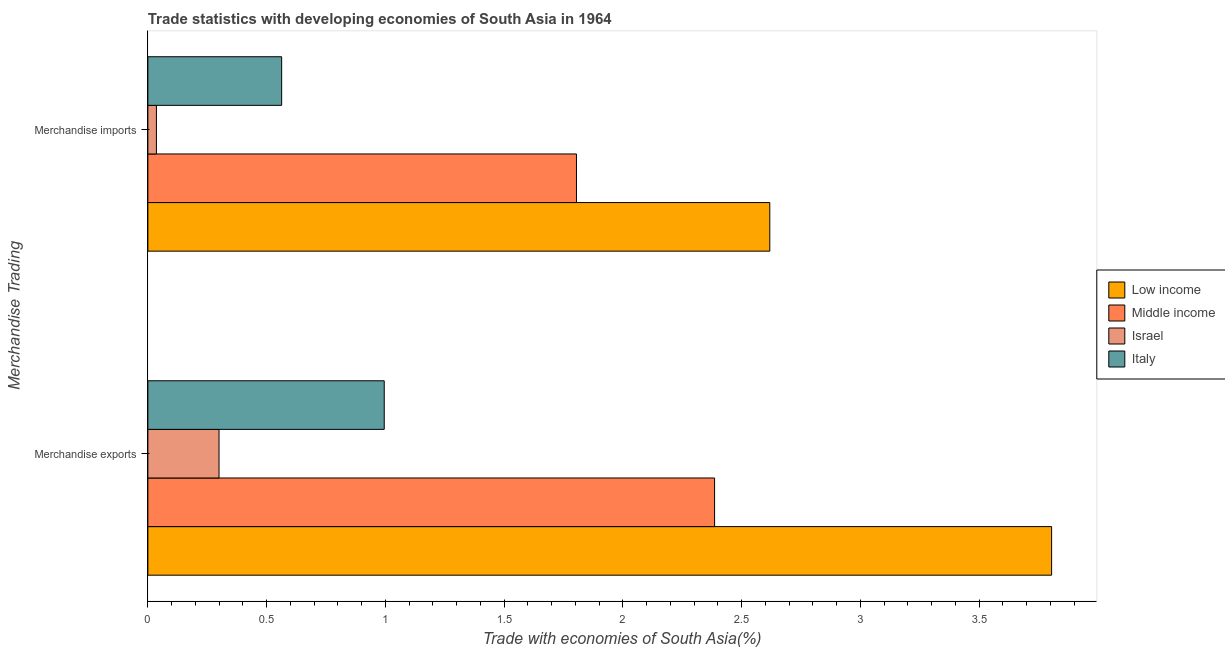How many different coloured bars are there?
Provide a short and direct response. 4. How many bars are there on the 2nd tick from the bottom?
Your answer should be very brief. 4. What is the merchandise imports in Israel?
Keep it short and to the point. 0.04. Across all countries, what is the maximum merchandise exports?
Your answer should be very brief. 3.81. Across all countries, what is the minimum merchandise exports?
Your answer should be compact. 0.3. In which country was the merchandise exports maximum?
Your response must be concise. Low income. In which country was the merchandise imports minimum?
Offer a very short reply. Israel. What is the total merchandise imports in the graph?
Offer a very short reply. 5.02. What is the difference between the merchandise exports in Israel and that in Low income?
Offer a terse response. -3.51. What is the difference between the merchandise exports in Israel and the merchandise imports in Middle income?
Keep it short and to the point. -1.51. What is the average merchandise exports per country?
Offer a very short reply. 1.87. What is the difference between the merchandise imports and merchandise exports in Israel?
Offer a very short reply. -0.26. In how many countries, is the merchandise exports greater than 3.8 %?
Provide a short and direct response. 1. What is the ratio of the merchandise imports in Israel to that in Low income?
Keep it short and to the point. 0.01. Is the merchandise imports in Italy less than that in Low income?
Your response must be concise. Yes. What does the 4th bar from the bottom in Merchandise exports represents?
Provide a short and direct response. Italy. Are all the bars in the graph horizontal?
Make the answer very short. Yes. How many countries are there in the graph?
Give a very brief answer. 4. What is the difference between two consecutive major ticks on the X-axis?
Give a very brief answer. 0.5. Are the values on the major ticks of X-axis written in scientific E-notation?
Ensure brevity in your answer.  No. Does the graph contain grids?
Provide a succinct answer. No. How are the legend labels stacked?
Your response must be concise. Vertical. What is the title of the graph?
Your answer should be very brief. Trade statistics with developing economies of South Asia in 1964. Does "Philippines" appear as one of the legend labels in the graph?
Offer a very short reply. No. What is the label or title of the X-axis?
Ensure brevity in your answer.  Trade with economies of South Asia(%). What is the label or title of the Y-axis?
Provide a succinct answer. Merchandise Trading. What is the Trade with economies of South Asia(%) of Low income in Merchandise exports?
Offer a terse response. 3.81. What is the Trade with economies of South Asia(%) in Middle income in Merchandise exports?
Offer a terse response. 2.39. What is the Trade with economies of South Asia(%) of Israel in Merchandise exports?
Make the answer very short. 0.3. What is the Trade with economies of South Asia(%) of Italy in Merchandise exports?
Provide a short and direct response. 1. What is the Trade with economies of South Asia(%) of Low income in Merchandise imports?
Offer a terse response. 2.62. What is the Trade with economies of South Asia(%) in Middle income in Merchandise imports?
Offer a very short reply. 1.8. What is the Trade with economies of South Asia(%) of Israel in Merchandise imports?
Keep it short and to the point. 0.04. What is the Trade with economies of South Asia(%) in Italy in Merchandise imports?
Make the answer very short. 0.56. Across all Merchandise Trading, what is the maximum Trade with economies of South Asia(%) in Low income?
Provide a succinct answer. 3.81. Across all Merchandise Trading, what is the maximum Trade with economies of South Asia(%) in Middle income?
Ensure brevity in your answer.  2.39. Across all Merchandise Trading, what is the maximum Trade with economies of South Asia(%) in Israel?
Your response must be concise. 0.3. Across all Merchandise Trading, what is the maximum Trade with economies of South Asia(%) of Italy?
Provide a short and direct response. 1. Across all Merchandise Trading, what is the minimum Trade with economies of South Asia(%) in Low income?
Offer a very short reply. 2.62. Across all Merchandise Trading, what is the minimum Trade with economies of South Asia(%) of Middle income?
Offer a very short reply. 1.8. Across all Merchandise Trading, what is the minimum Trade with economies of South Asia(%) in Israel?
Give a very brief answer. 0.04. Across all Merchandise Trading, what is the minimum Trade with economies of South Asia(%) of Italy?
Keep it short and to the point. 0.56. What is the total Trade with economies of South Asia(%) in Low income in the graph?
Your answer should be very brief. 6.42. What is the total Trade with economies of South Asia(%) of Middle income in the graph?
Give a very brief answer. 4.19. What is the total Trade with economies of South Asia(%) of Israel in the graph?
Your response must be concise. 0.34. What is the total Trade with economies of South Asia(%) in Italy in the graph?
Make the answer very short. 1.56. What is the difference between the Trade with economies of South Asia(%) of Low income in Merchandise exports and that in Merchandise imports?
Your answer should be compact. 1.19. What is the difference between the Trade with economies of South Asia(%) in Middle income in Merchandise exports and that in Merchandise imports?
Give a very brief answer. 0.58. What is the difference between the Trade with economies of South Asia(%) of Israel in Merchandise exports and that in Merchandise imports?
Your answer should be very brief. 0.26. What is the difference between the Trade with economies of South Asia(%) of Italy in Merchandise exports and that in Merchandise imports?
Keep it short and to the point. 0.43. What is the difference between the Trade with economies of South Asia(%) in Low income in Merchandise exports and the Trade with economies of South Asia(%) in Middle income in Merchandise imports?
Give a very brief answer. 2. What is the difference between the Trade with economies of South Asia(%) in Low income in Merchandise exports and the Trade with economies of South Asia(%) in Israel in Merchandise imports?
Give a very brief answer. 3.77. What is the difference between the Trade with economies of South Asia(%) of Low income in Merchandise exports and the Trade with economies of South Asia(%) of Italy in Merchandise imports?
Provide a succinct answer. 3.24. What is the difference between the Trade with economies of South Asia(%) in Middle income in Merchandise exports and the Trade with economies of South Asia(%) in Israel in Merchandise imports?
Offer a very short reply. 2.35. What is the difference between the Trade with economies of South Asia(%) in Middle income in Merchandise exports and the Trade with economies of South Asia(%) in Italy in Merchandise imports?
Give a very brief answer. 1.82. What is the difference between the Trade with economies of South Asia(%) of Israel in Merchandise exports and the Trade with economies of South Asia(%) of Italy in Merchandise imports?
Make the answer very short. -0.26. What is the average Trade with economies of South Asia(%) in Low income per Merchandise Trading?
Provide a short and direct response. 3.21. What is the average Trade with economies of South Asia(%) in Middle income per Merchandise Trading?
Your response must be concise. 2.1. What is the average Trade with economies of South Asia(%) in Israel per Merchandise Trading?
Keep it short and to the point. 0.17. What is the average Trade with economies of South Asia(%) in Italy per Merchandise Trading?
Keep it short and to the point. 0.78. What is the difference between the Trade with economies of South Asia(%) of Low income and Trade with economies of South Asia(%) of Middle income in Merchandise exports?
Your response must be concise. 1.42. What is the difference between the Trade with economies of South Asia(%) in Low income and Trade with economies of South Asia(%) in Israel in Merchandise exports?
Your answer should be very brief. 3.51. What is the difference between the Trade with economies of South Asia(%) in Low income and Trade with economies of South Asia(%) in Italy in Merchandise exports?
Your answer should be very brief. 2.81. What is the difference between the Trade with economies of South Asia(%) of Middle income and Trade with economies of South Asia(%) of Israel in Merchandise exports?
Offer a terse response. 2.09. What is the difference between the Trade with economies of South Asia(%) in Middle income and Trade with economies of South Asia(%) in Italy in Merchandise exports?
Give a very brief answer. 1.39. What is the difference between the Trade with economies of South Asia(%) in Israel and Trade with economies of South Asia(%) in Italy in Merchandise exports?
Give a very brief answer. -0.7. What is the difference between the Trade with economies of South Asia(%) in Low income and Trade with economies of South Asia(%) in Middle income in Merchandise imports?
Keep it short and to the point. 0.81. What is the difference between the Trade with economies of South Asia(%) of Low income and Trade with economies of South Asia(%) of Israel in Merchandise imports?
Provide a short and direct response. 2.58. What is the difference between the Trade with economies of South Asia(%) in Low income and Trade with economies of South Asia(%) in Italy in Merchandise imports?
Make the answer very short. 2.06. What is the difference between the Trade with economies of South Asia(%) in Middle income and Trade with economies of South Asia(%) in Israel in Merchandise imports?
Your answer should be very brief. 1.77. What is the difference between the Trade with economies of South Asia(%) of Middle income and Trade with economies of South Asia(%) of Italy in Merchandise imports?
Your answer should be compact. 1.24. What is the difference between the Trade with economies of South Asia(%) in Israel and Trade with economies of South Asia(%) in Italy in Merchandise imports?
Your answer should be compact. -0.53. What is the ratio of the Trade with economies of South Asia(%) of Low income in Merchandise exports to that in Merchandise imports?
Ensure brevity in your answer.  1.45. What is the ratio of the Trade with economies of South Asia(%) in Middle income in Merchandise exports to that in Merchandise imports?
Make the answer very short. 1.32. What is the ratio of the Trade with economies of South Asia(%) of Israel in Merchandise exports to that in Merchandise imports?
Provide a succinct answer. 8.32. What is the ratio of the Trade with economies of South Asia(%) of Italy in Merchandise exports to that in Merchandise imports?
Your answer should be very brief. 1.77. What is the difference between the highest and the second highest Trade with economies of South Asia(%) of Low income?
Provide a short and direct response. 1.19. What is the difference between the highest and the second highest Trade with economies of South Asia(%) in Middle income?
Your answer should be compact. 0.58. What is the difference between the highest and the second highest Trade with economies of South Asia(%) in Israel?
Provide a succinct answer. 0.26. What is the difference between the highest and the second highest Trade with economies of South Asia(%) in Italy?
Make the answer very short. 0.43. What is the difference between the highest and the lowest Trade with economies of South Asia(%) in Low income?
Make the answer very short. 1.19. What is the difference between the highest and the lowest Trade with economies of South Asia(%) in Middle income?
Give a very brief answer. 0.58. What is the difference between the highest and the lowest Trade with economies of South Asia(%) in Israel?
Offer a very short reply. 0.26. What is the difference between the highest and the lowest Trade with economies of South Asia(%) of Italy?
Provide a succinct answer. 0.43. 